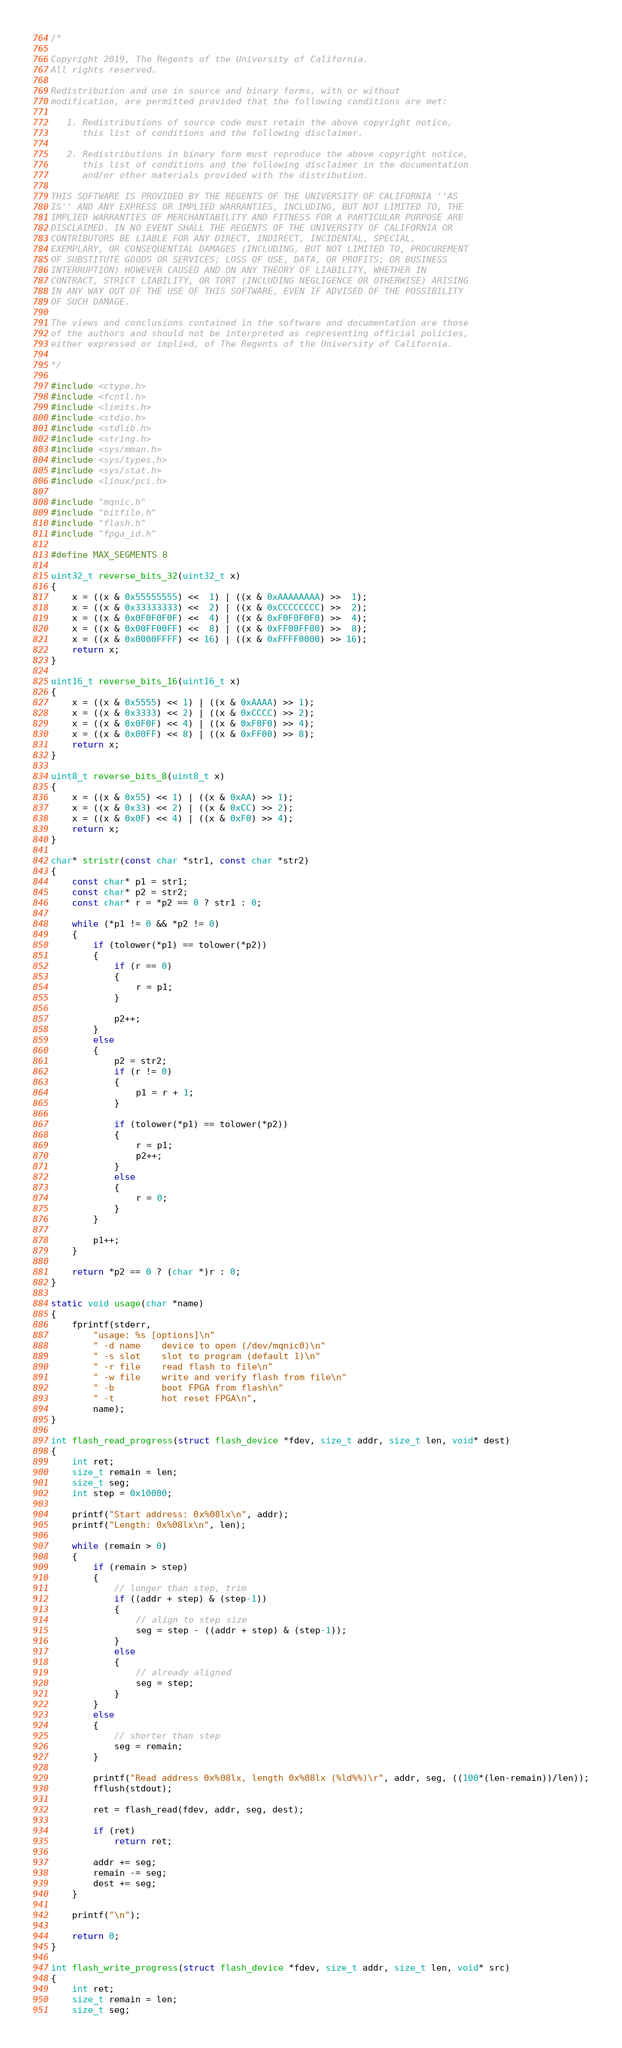Convert code to text. <code><loc_0><loc_0><loc_500><loc_500><_C_>/*

Copyright 2019, The Regents of the University of California.
All rights reserved.

Redistribution and use in source and binary forms, with or without
modification, are permitted provided that the following conditions are met:

   1. Redistributions of source code must retain the above copyright notice,
      this list of conditions and the following disclaimer.

   2. Redistributions in binary form must reproduce the above copyright notice,
      this list of conditions and the following disclaimer in the documentation
      and/or other materials provided with the distribution.

THIS SOFTWARE IS PROVIDED BY THE REGENTS OF THE UNIVERSITY OF CALIFORNIA ''AS
IS'' AND ANY EXPRESS OR IMPLIED WARRANTIES, INCLUDING, BUT NOT LIMITED TO, THE
IMPLIED WARRANTIES OF MERCHANTABILITY AND FITNESS FOR A PARTICULAR PURPOSE ARE
DISCLAIMED. IN NO EVENT SHALL THE REGENTS OF THE UNIVERSITY OF CALIFORNIA OR
CONTRIBUTORS BE LIABLE FOR ANY DIRECT, INDIRECT, INCIDENTAL, SPECIAL,
EXEMPLARY, OR CONSEQUENTIAL DAMAGES (INCLUDING, BUT NOT LIMITED TO, PROCUREMENT
OF SUBSTITUTE GOODS OR SERVICES; LOSS OF USE, DATA, OR PROFITS; OR BUSINESS
INTERRUPTION) HOWEVER CAUSED AND ON ANY THEORY OF LIABILITY, WHETHER IN
CONTRACT, STRICT LIABILITY, OR TORT (INCLUDING NEGLIGENCE OR OTHERWISE) ARISING
IN ANY WAY OUT OF THE USE OF THIS SOFTWARE, EVEN IF ADVISED OF THE POSSIBILITY
OF SUCH DAMAGE.

The views and conclusions contained in the software and documentation are those
of the authors and should not be interpreted as representing official policies,
either expressed or implied, of The Regents of the University of California.

*/

#include <ctype.h>
#include <fcntl.h>
#include <limits.h>
#include <stdio.h>
#include <stdlib.h>
#include <string.h>
#include <sys/mman.h>
#include <sys/types.h>
#include <sys/stat.h>
#include <linux/pci.h>

#include "mqnic.h"
#include "bitfile.h"
#include "flash.h"
#include "fpga_id.h"

#define MAX_SEGMENTS 8

uint32_t reverse_bits_32(uint32_t x)
{
    x = ((x & 0x55555555) <<  1) | ((x & 0xAAAAAAAA) >>  1);
    x = ((x & 0x33333333) <<  2) | ((x & 0xCCCCCCCC) >>  2);
    x = ((x & 0x0F0F0F0F) <<  4) | ((x & 0xF0F0F0F0) >>  4);
    x = ((x & 0x00FF00FF) <<  8) | ((x & 0xFF00FF00) >>  8);
    x = ((x & 0x0000FFFF) << 16) | ((x & 0xFFFF0000) >> 16);
    return x;
}

uint16_t reverse_bits_16(uint16_t x)
{
    x = ((x & 0x5555) << 1) | ((x & 0xAAAA) >> 1);
    x = ((x & 0x3333) << 2) | ((x & 0xCCCC) >> 2);
    x = ((x & 0x0F0F) << 4) | ((x & 0xF0F0) >> 4);
    x = ((x & 0x00FF) << 8) | ((x & 0xFF00) >> 8);
    return x;
}

uint8_t reverse_bits_8(uint8_t x)
{
    x = ((x & 0x55) << 1) | ((x & 0xAA) >> 1);
    x = ((x & 0x33) << 2) | ((x & 0xCC) >> 2);
    x = ((x & 0x0F) << 4) | ((x & 0xF0) >> 4);
    return x;
}

char* stristr(const char *str1, const char *str2)
{
    const char* p1 = str1;
    const char* p2 = str2;
    const char* r = *p2 == 0 ? str1 : 0;

    while (*p1 != 0 && *p2 != 0)
    {
        if (tolower(*p1) == tolower(*p2))
        {
            if (r == 0)
            {
                r = p1;
            }

            p2++;
        }
        else
        {
            p2 = str2;
            if (r != 0)
            {
                p1 = r + 1;
            }

            if (tolower(*p1) == tolower(*p2))
            {
                r = p1;
                p2++;
            }
            else
            {
                r = 0;
            }
        }

        p1++;
    }

    return *p2 == 0 ? (char *)r : 0;
}

static void usage(char *name)
{
    fprintf(stderr,
        "usage: %s [options]\n"
        " -d name    device to open (/dev/mqnic0)\n"
        " -s slot    slot to program (default 1)\n"
        " -r file    read flash to file\n"
        " -w file    write and verify flash from file\n"
        " -b         boot FPGA from flash\n"
        " -t         hot reset FPGA\n",
        name);
}

int flash_read_progress(struct flash_device *fdev, size_t addr, size_t len, void* dest)
{
    int ret;
    size_t remain = len;
    size_t seg;
    int step = 0x10000;

    printf("Start address: 0x%08lx\n", addr);
    printf("Length: 0x%08lx\n", len);

    while (remain > 0)
    {
        if (remain > step)
        {
            // longer than step, trim
            if ((addr + step) & (step-1))
            {
                // align to step size
                seg = step - ((addr + step) & (step-1));
            }
            else
            {
                // already aligned
                seg = step;
            }
        }
        else
        {
            // shorter than step
            seg = remain;
        }

        printf("Read address 0x%08lx, length 0x%08lx (%ld%%)\r", addr, seg, ((100*(len-remain))/len));
        fflush(stdout);

        ret = flash_read(fdev, addr, seg, dest);

        if (ret)
            return ret;

        addr += seg;
        remain -= seg;
        dest += seg;
    }

    printf("\n");

    return 0;
}

int flash_write_progress(struct flash_device *fdev, size_t addr, size_t len, void* src)
{
    int ret;
    size_t remain = len;
    size_t seg;</code> 